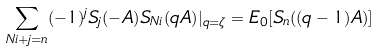Convert formula to latex. <formula><loc_0><loc_0><loc_500><loc_500>\sum _ { N i + j = n } ( - 1 ) ^ { j } S _ { j } ( - A ) S _ { N i } ( q A ) | _ { q = \zeta } = E _ { 0 } [ S _ { n } ( ( q - 1 ) A ) ]</formula> 